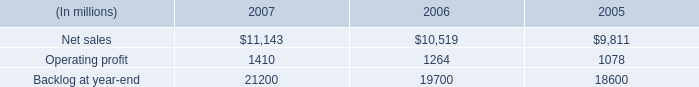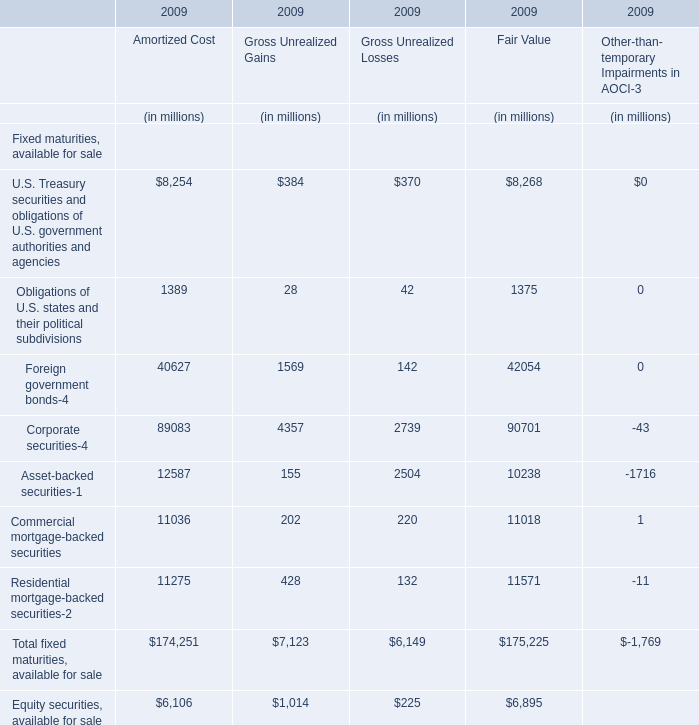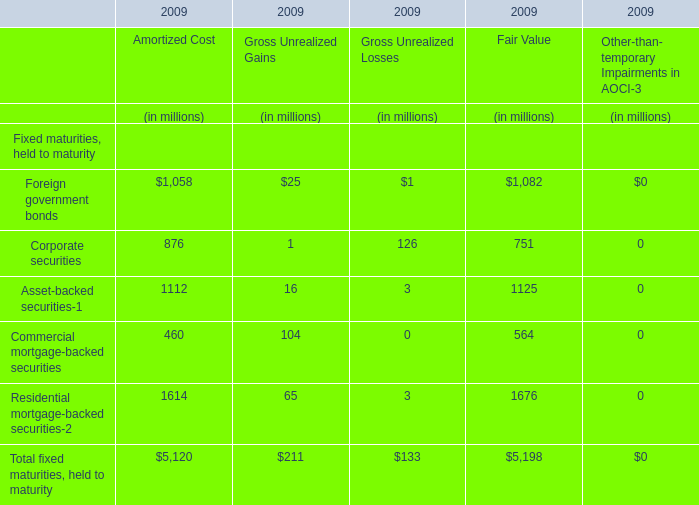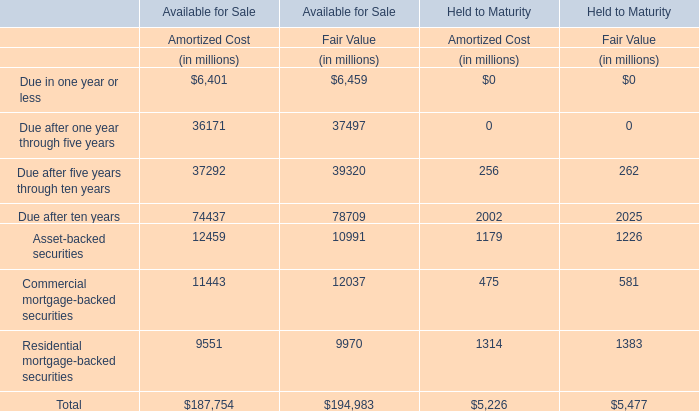What's the 50 % of the Fair Value for the Corporate securities in 2009? (in million) 
Computations: (0.5 * 751)
Answer: 375.5. 